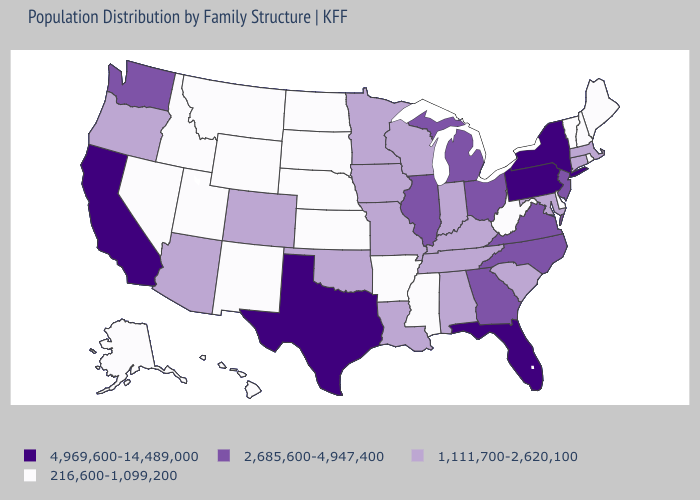What is the value of Utah?
Answer briefly. 216,600-1,099,200. Does Michigan have the lowest value in the USA?
Keep it brief. No. How many symbols are there in the legend?
Write a very short answer. 4. Name the states that have a value in the range 216,600-1,099,200?
Keep it brief. Alaska, Arkansas, Delaware, Hawaii, Idaho, Kansas, Maine, Mississippi, Montana, Nebraska, Nevada, New Hampshire, New Mexico, North Dakota, Rhode Island, South Dakota, Utah, Vermont, West Virginia, Wyoming. Among the states that border Kansas , which have the highest value?
Keep it brief. Colorado, Missouri, Oklahoma. Does New Hampshire have a lower value than Vermont?
Concise answer only. No. Name the states that have a value in the range 4,969,600-14,489,000?
Keep it brief. California, Florida, New York, Pennsylvania, Texas. What is the value of Connecticut?
Concise answer only. 1,111,700-2,620,100. Name the states that have a value in the range 216,600-1,099,200?
Write a very short answer. Alaska, Arkansas, Delaware, Hawaii, Idaho, Kansas, Maine, Mississippi, Montana, Nebraska, Nevada, New Hampshire, New Mexico, North Dakota, Rhode Island, South Dakota, Utah, Vermont, West Virginia, Wyoming. What is the highest value in the MidWest ?
Concise answer only. 2,685,600-4,947,400. Name the states that have a value in the range 4,969,600-14,489,000?
Give a very brief answer. California, Florida, New York, Pennsylvania, Texas. Which states have the lowest value in the USA?
Quick response, please. Alaska, Arkansas, Delaware, Hawaii, Idaho, Kansas, Maine, Mississippi, Montana, Nebraska, Nevada, New Hampshire, New Mexico, North Dakota, Rhode Island, South Dakota, Utah, Vermont, West Virginia, Wyoming. Name the states that have a value in the range 4,969,600-14,489,000?
Concise answer only. California, Florida, New York, Pennsylvania, Texas. What is the value of New Mexico?
Concise answer only. 216,600-1,099,200. Name the states that have a value in the range 1,111,700-2,620,100?
Give a very brief answer. Alabama, Arizona, Colorado, Connecticut, Indiana, Iowa, Kentucky, Louisiana, Maryland, Massachusetts, Minnesota, Missouri, Oklahoma, Oregon, South Carolina, Tennessee, Wisconsin. 